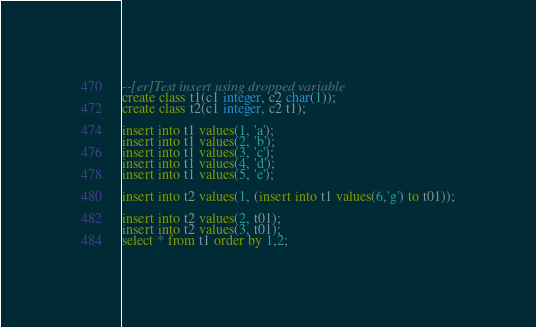Convert code to text. <code><loc_0><loc_0><loc_500><loc_500><_SQL_>--[er]Test insert using dropped variable
create class t1(c1 integer, c2 char(1));
create class t2(c1 integer, c2 t1);

insert into t1 values(1, 'a');
insert into t1 values(2, 'b');
insert into t1 values(3, 'c');
insert into t1 values(4, 'd');
insert into t1 values(5, 'e');

insert into t2 values(1, (insert into t1 values(6,'g') to t01));

insert into t2 values(2, t01);
insert into t2 values(3, t01);
select * from t1 order by 1,2;</code> 